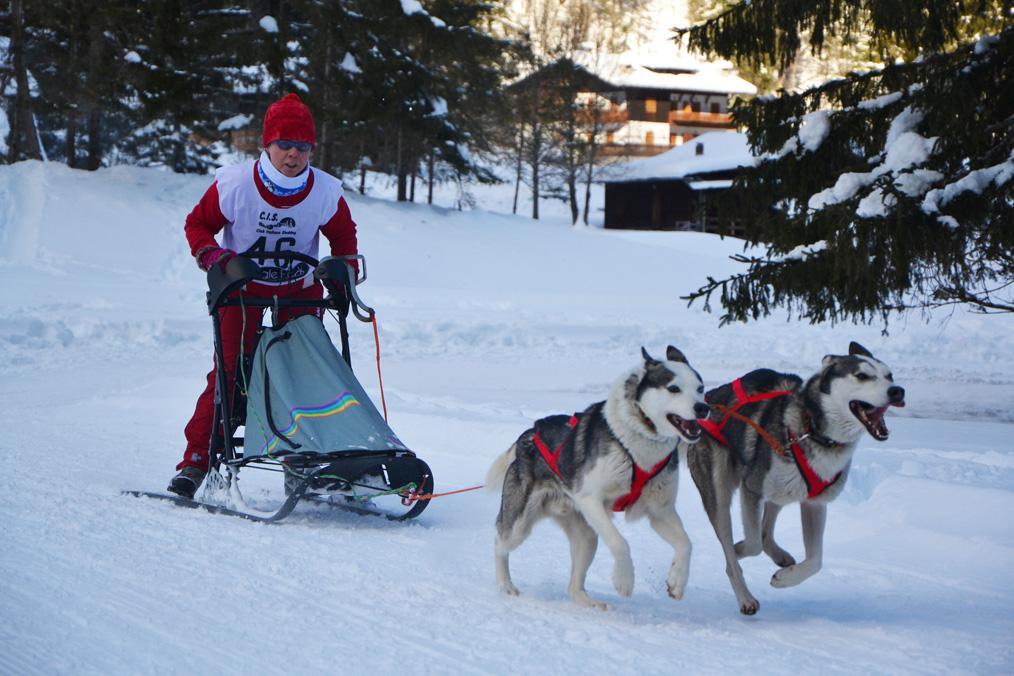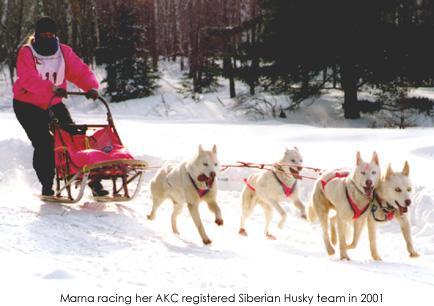The first image is the image on the left, the second image is the image on the right. For the images displayed, is the sentence "The dog sled teams in the left and right images move forward over snow at some angle [instead of away from the camera] but are not heading toward each other." factually correct? Answer yes or no. Yes. The first image is the image on the left, the second image is the image on the right. Considering the images on both sides, is "In the left image, all dogs have blue harnesses." valid? Answer yes or no. No. 